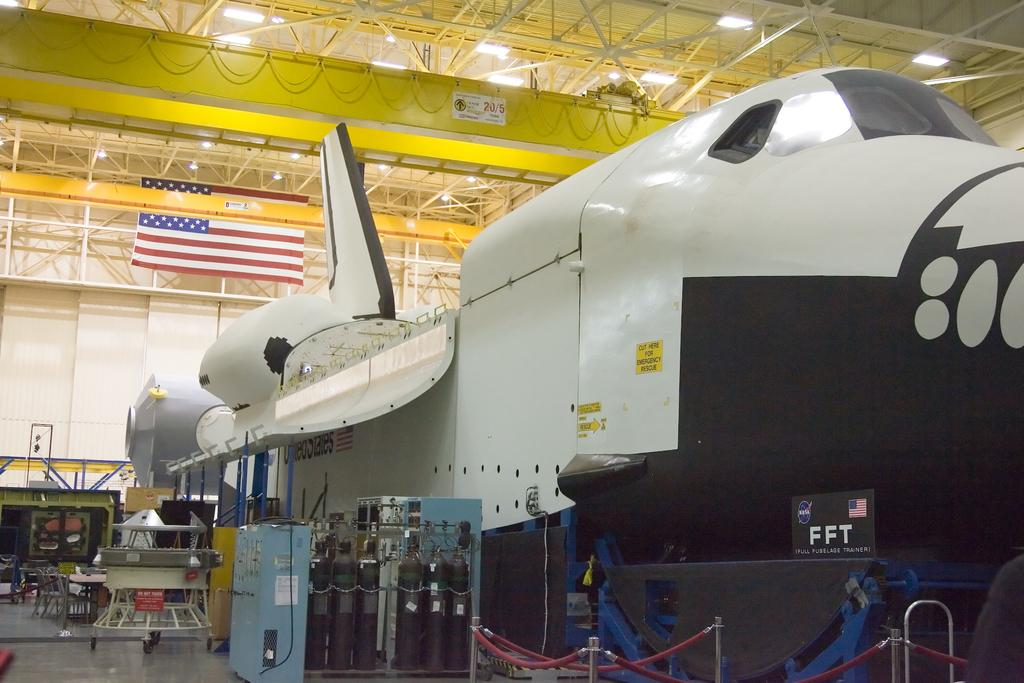<image>
Provide a brief description of the given image. A plane inside a hangar with the letters FFT on the front. 